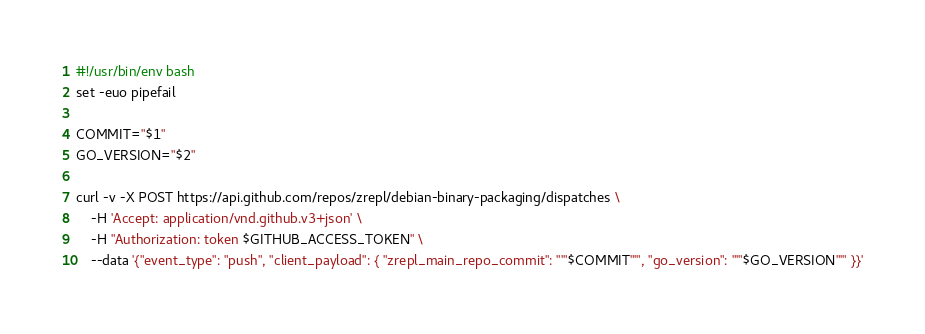Convert code to text. <code><loc_0><loc_0><loc_500><loc_500><_Bash_>#!/usr/bin/env bash
set -euo pipefail

COMMIT="$1"
GO_VERSION="$2"

curl -v -X POST https://api.github.com/repos/zrepl/debian-binary-packaging/dispatches \
    -H 'Accept: application/vnd.github.v3+json' \
    -H "Authorization: token $GITHUB_ACCESS_TOKEN" \
    --data '{"event_type": "push", "client_payload": { "zrepl_main_repo_commit": "'"$COMMIT"'", "go_version": "'"$GO_VERSION"'" }}'
</code> 